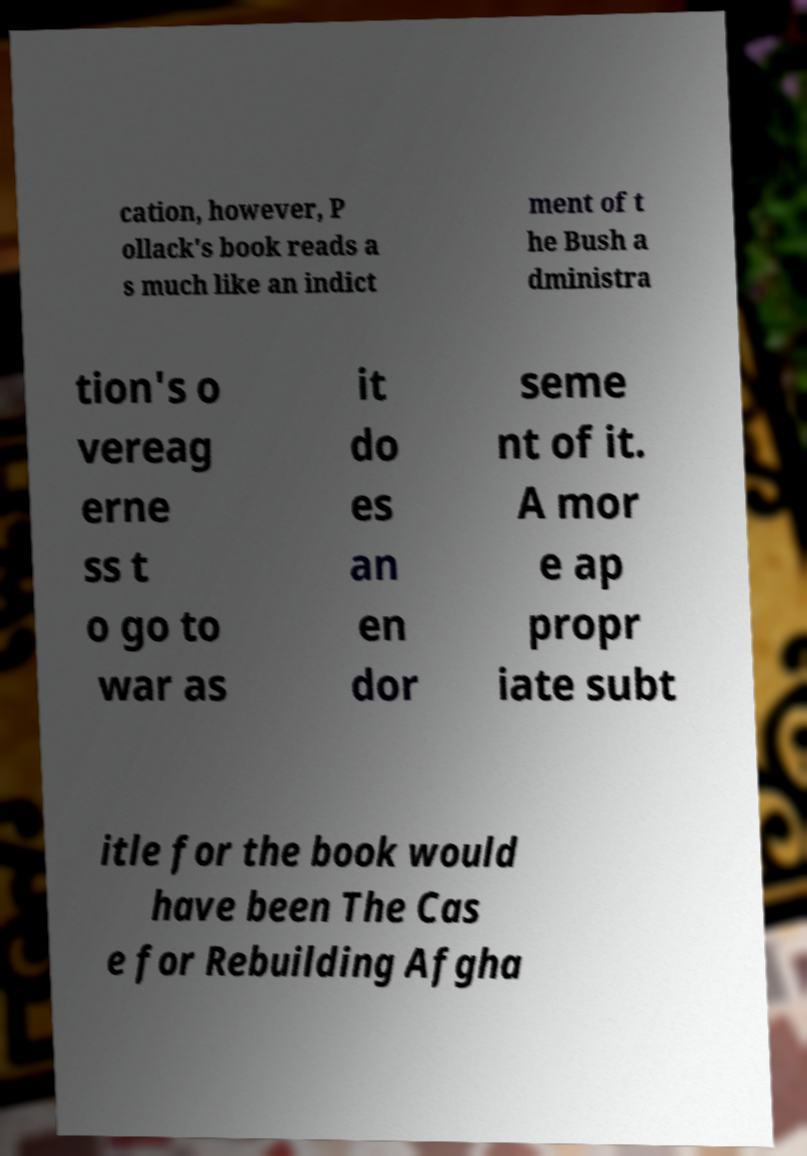Could you assist in decoding the text presented in this image and type it out clearly? cation, however, P ollack's book reads a s much like an indict ment of t he Bush a dministra tion's o vereag erne ss t o go to war as it do es an en dor seme nt of it. A mor e ap propr iate subt itle for the book would have been The Cas e for Rebuilding Afgha 